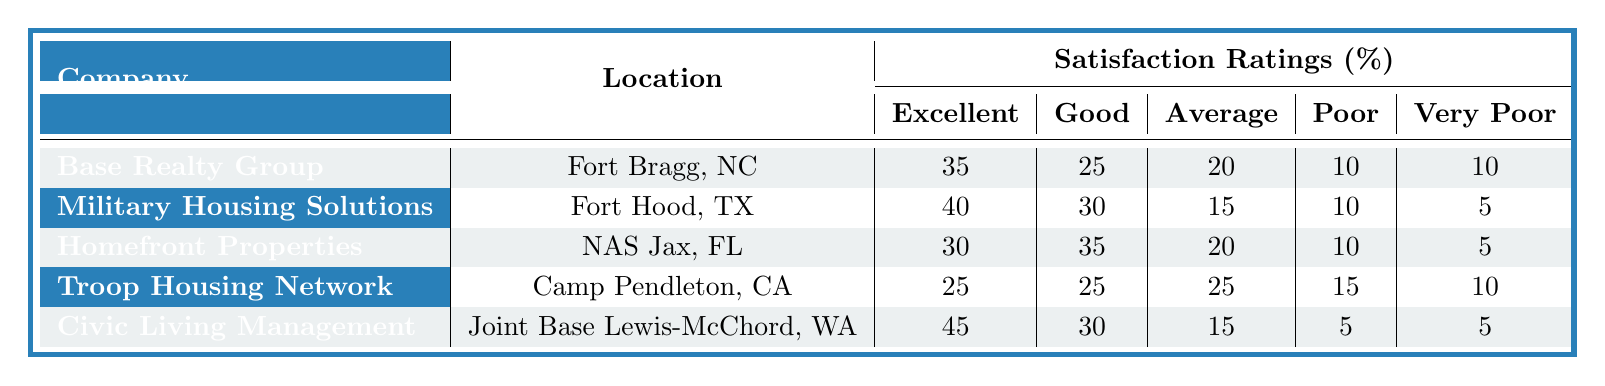What is the location of Civic Living Management? According to the table, Civic Living Management is located at Joint Base Lewis-McChord, WA.
Answer: Joint Base Lewis-McChord, WA Which property management company received the highest satisfaction rating in the "Excellent" category? By looking at the "Excellent" row, Civic Living Management has the highest rating at 45%, compared to other companies.
Answer: Civic Living Management What is the total percentage of "Poor" and "Very Poor" ratings for Homefront Properties? For Homefront Properties, the "Poor" rating is 10% and the "Very Poor" rating is 5%. Adding these together gives 10 + 5 = 15%.
Answer: 15% Is it true that all property management companies received at least 25% in the "Good" rating category? Checking the "Good" ratings, all companies have scores of 25% or higher in this category: Base Realty Group (25%), Military Housing Solutions (30%), Homefront Properties (35%), Troop Housing Network (25%), and Civic Living Management (30%). Therefore, the statement is true.
Answer: Yes What is the average percentage of "Average" ratings across all property management companies? Summing the "Average" ratings: (20 + 15 + 20 + 25 + 15) = 95. Dividing by the number of companies (5) gives an average of 95 / 5 = 19%.
Answer: 19% Which property management company has the lowest total satisfaction ratings when considering "Poor" and "Very Poor" together? The "Poor" and "Very Poor" ratings are as follows: Base Realty Group (10 + 10 = 20), Military Housing Solutions (10 + 5 = 15), Homefront Properties (10 + 5 = 15), Troop Housing Network (15 + 10 = 25), Civic Living Management (5 + 5 = 10). The lowest combined total is from Civic Living Management with 10%.
Answer: Civic Living Management 